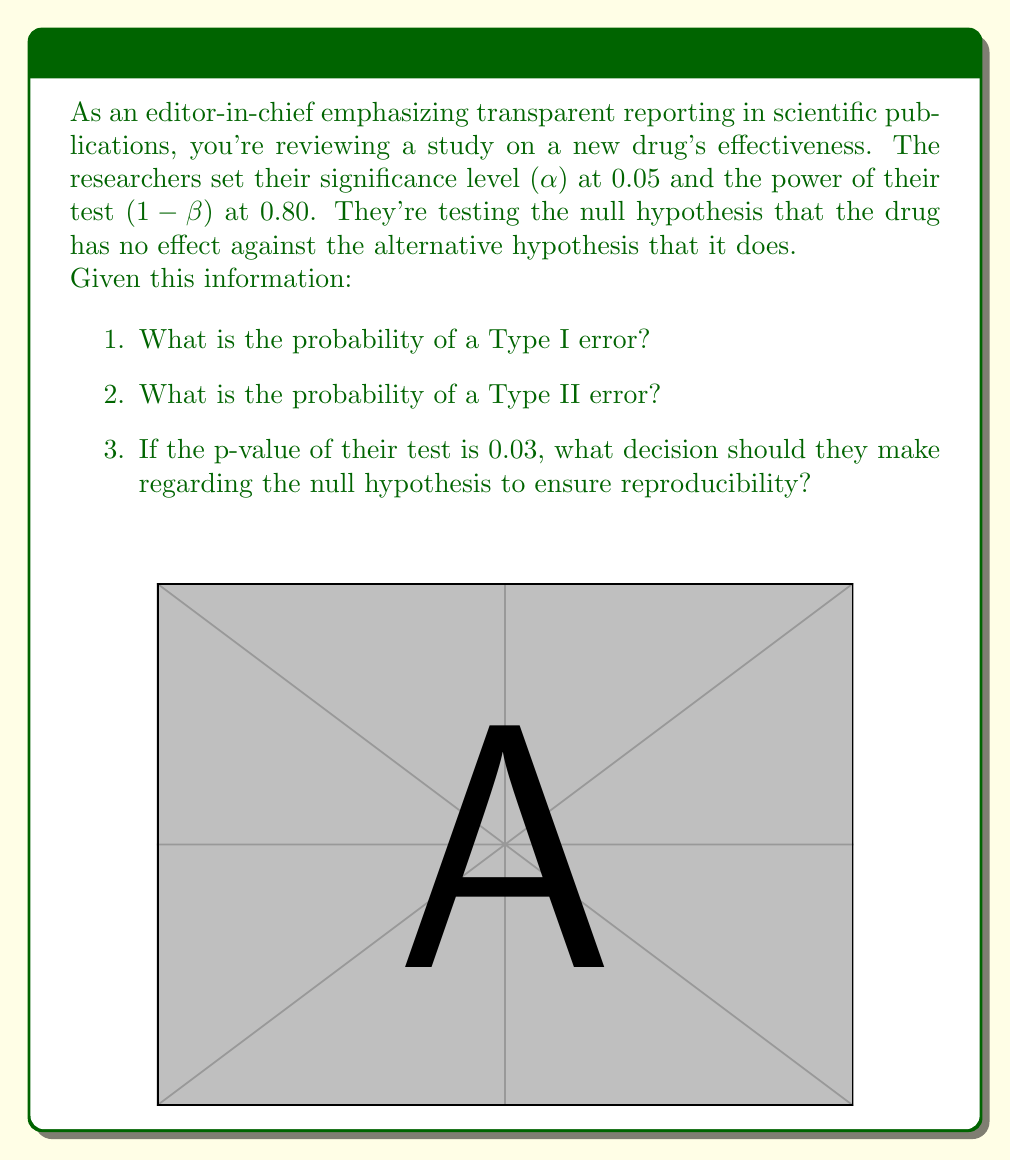Solve this math problem. Let's break this down step-by-step:

1. Probability of a Type I error:
   The Type I error rate is equal to the significance level (α). In this case:
   $$P(\text{Type I error}) = \alpha = 0.05$$

2. Probability of a Type II error:
   The power of the test is given as 1 - β, where β is the probability of a Type II error. Therefore:
   $$1 - \beta = 0.80$$
   $$\beta = 1 - 0.80 = 0.20$$
   $$P(\text{Type II error}) = \beta = 0.20$$

3. Decision regarding the null hypothesis:
   The p-value (0.03) is less than the significance level (α = 0.05). In hypothesis testing:
   
   If $p < \alpha$, reject the null hypothesis.
   If $p \geq \alpha$, fail to reject the null hypothesis.

   Here, $0.03 < 0.05$, so the researchers should reject the null hypothesis.

   To ensure reproducibility, it's crucial to report:
   - The exact p-value (0.03)
   - The significance level used (0.05)
   - The power of the test (0.80)
   - The effect size (if available)

   This transparent reporting allows other researchers to fully understand and potentially replicate the study.
Answer: 1. 0.05
2. 0.20
3. Reject $H_0$; report p-value, α, power, and effect size 